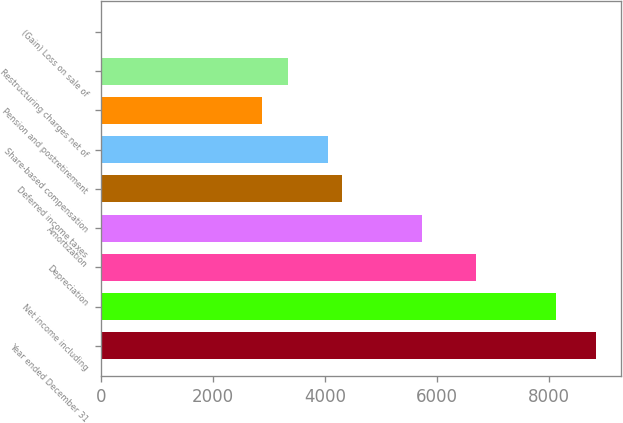Convert chart. <chart><loc_0><loc_0><loc_500><loc_500><bar_chart><fcel>Year ended December 31<fcel>Net income including<fcel>Depreciation<fcel>Amortization<fcel>Deferred income taxes<fcel>Share-based compensation<fcel>Pension and postretirement<fcel>Restructuring charges net of<fcel>(Gain) Loss on sale of<nl><fcel>8841.65<fcel>8124.8<fcel>6691.1<fcel>5735.3<fcel>4301.6<fcel>4062.65<fcel>2867.9<fcel>3345.8<fcel>0.5<nl></chart> 